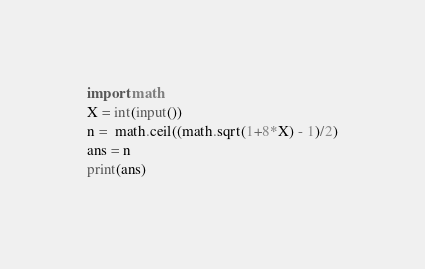<code> <loc_0><loc_0><loc_500><loc_500><_Python_>import math
X = int(input())
n =  math.ceil((math.sqrt(1+8*X) - 1)/2)
ans = n
print(ans)
</code> 